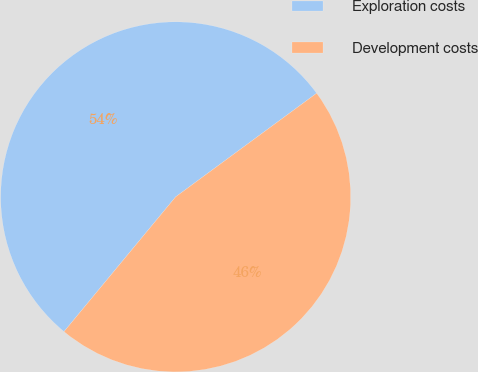Convert chart to OTSL. <chart><loc_0><loc_0><loc_500><loc_500><pie_chart><fcel>Exploration costs<fcel>Development costs<nl><fcel>53.9%<fcel>46.1%<nl></chart> 